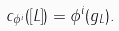<formula> <loc_0><loc_0><loc_500><loc_500>c _ { \phi ^ { i } } ( [ L ] ) = \phi ^ { i } ( g _ { L } ) .</formula> 